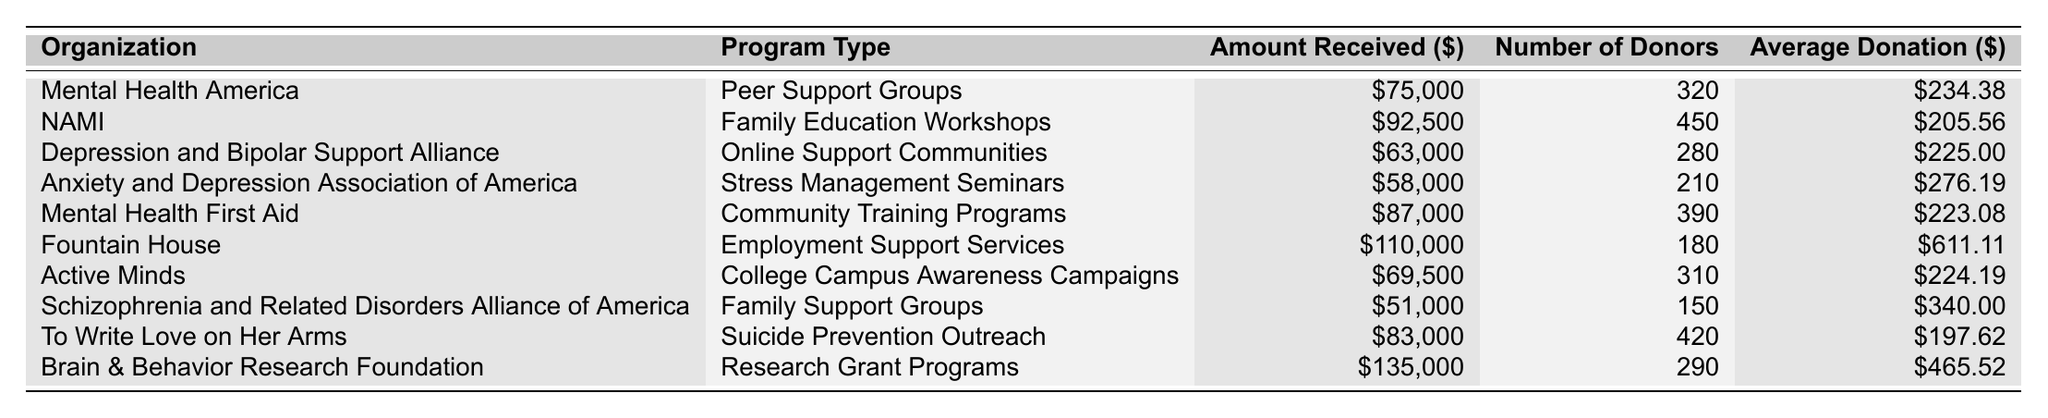What is the total amount received by all organizations combined? To find the total amount, sum all the amounts received: 75000 + 92500 + 63000 + 58000 + 87000 + 110000 + 69500 + 51000 + 83000 + 135000 =  75000 + 92500 + 63000 + 58000 + 87000 + 110000 + 69500 + 51000 + 83000 + 135000 =  872500
Answer: 872500 Which organization received the highest amount? The organization with the highest amount is Brain & Behavior Research Foundation, which received $135,000.
Answer: Brain & Behavior Research Foundation What is the average donation amount for the Anxiety and Depression Association of America? The average donation amount for the Anxiety and Depression Association of America is $276.19, as seen directly in the table under "Average Donation."
Answer: 276.19 How many donors contributed to the NAMI programs? NAMI had 450 donors contributing to their programs, which is stated in the "Number of Donors" column for that row.
Answer: 450 Which program type received the least amount of donations? The program type that received the least amount is Family Support Groups with $51,000. You can find this value in the appropriate corresponding row.
Answer: Family Support Groups What is the total number of donors across all organizations? To get the total number of donors, add all the donors together: 320 + 450 + 280 + 210 + 390 + 180 + 310 + 150 + 420 + 290 = 2,700.
Answer: 2700 Is the average donation from the Fountain House higher than $600? The average donation from Fountain House is $611.11, which is above $600. This can be directly compared as stated in the table.
Answer: Yes What organization had the highest average donation per donor? The highest average donation per donor is attributed to Fountain House with $611.11. By checking the "Average Donation" column, it can be confirmed.
Answer: Fountain House Which program type had only 150 donors? The program type with only 150 donors is Family Support Groups by the Schizophrenia and Related Disorders Alliance of America. This information is in the table in the related row.
Answer: Family Support Groups What is the difference in the amount received between the highest and lowest amount organizations? The difference can be calculated by subtracting the lowest amount $51,000 from the highest amount $135,000, yielding $135,000 - $51,000 = $84,000.
Answer: 84000 